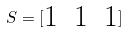<formula> <loc_0><loc_0><loc_500><loc_500>S = [ \begin{matrix} 1 & 1 & 1 \end{matrix} ]</formula> 